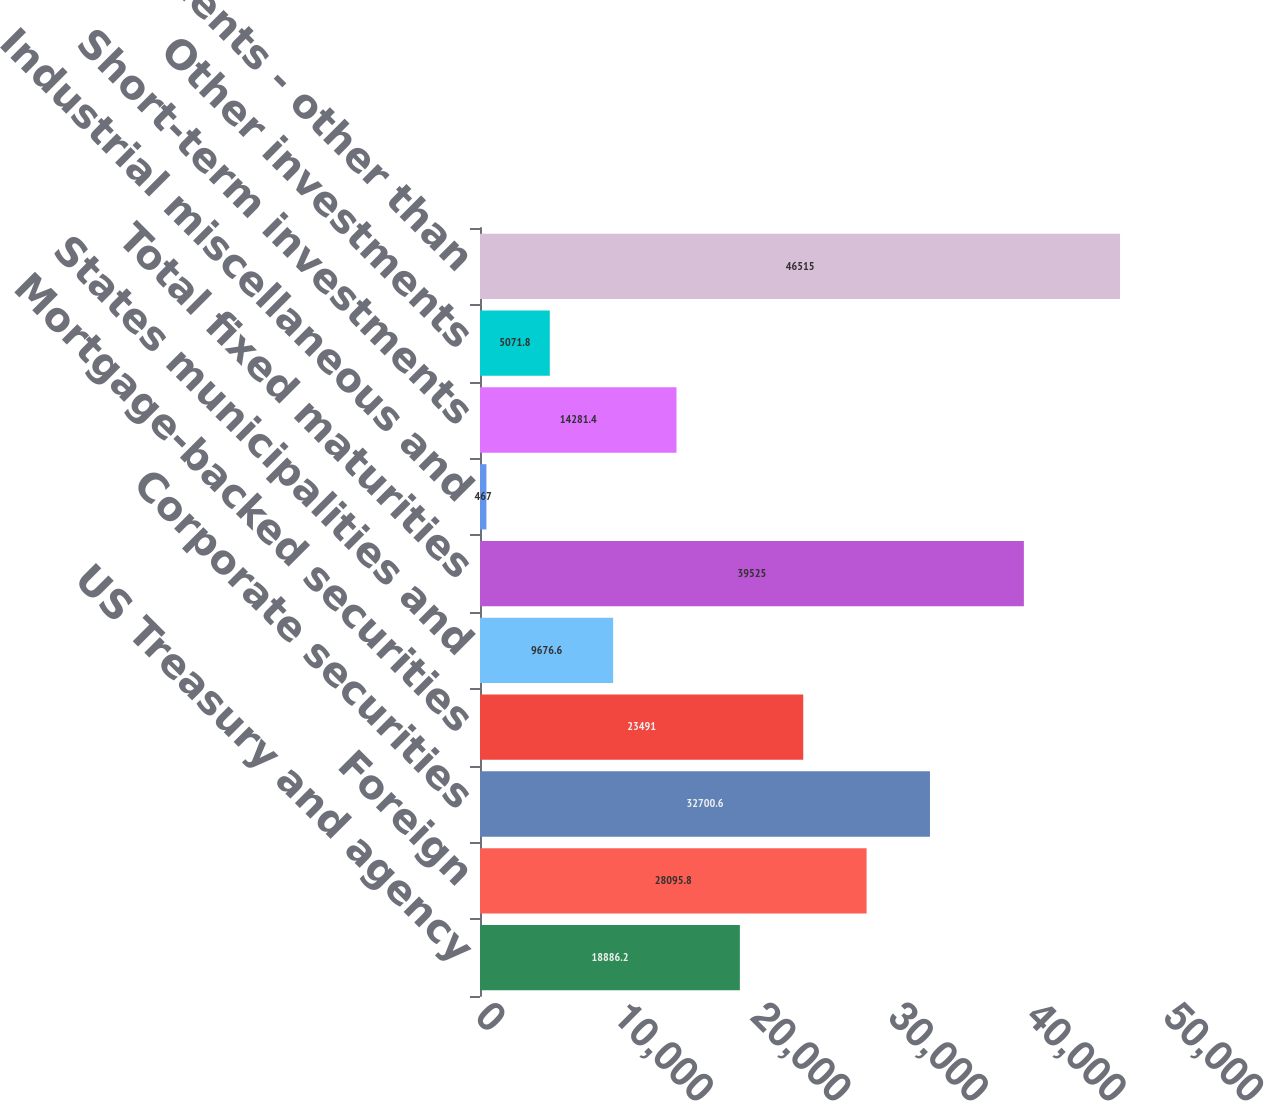Convert chart to OTSL. <chart><loc_0><loc_0><loc_500><loc_500><bar_chart><fcel>US Treasury and agency<fcel>Foreign<fcel>Corporate securities<fcel>Mortgage-backed securities<fcel>States municipalities and<fcel>Total fixed maturities<fcel>Industrial miscellaneous and<fcel>Short-term investments<fcel>Other investments<fcel>Total investments - other than<nl><fcel>18886.2<fcel>28095.8<fcel>32700.6<fcel>23491<fcel>9676.6<fcel>39525<fcel>467<fcel>14281.4<fcel>5071.8<fcel>46515<nl></chart> 